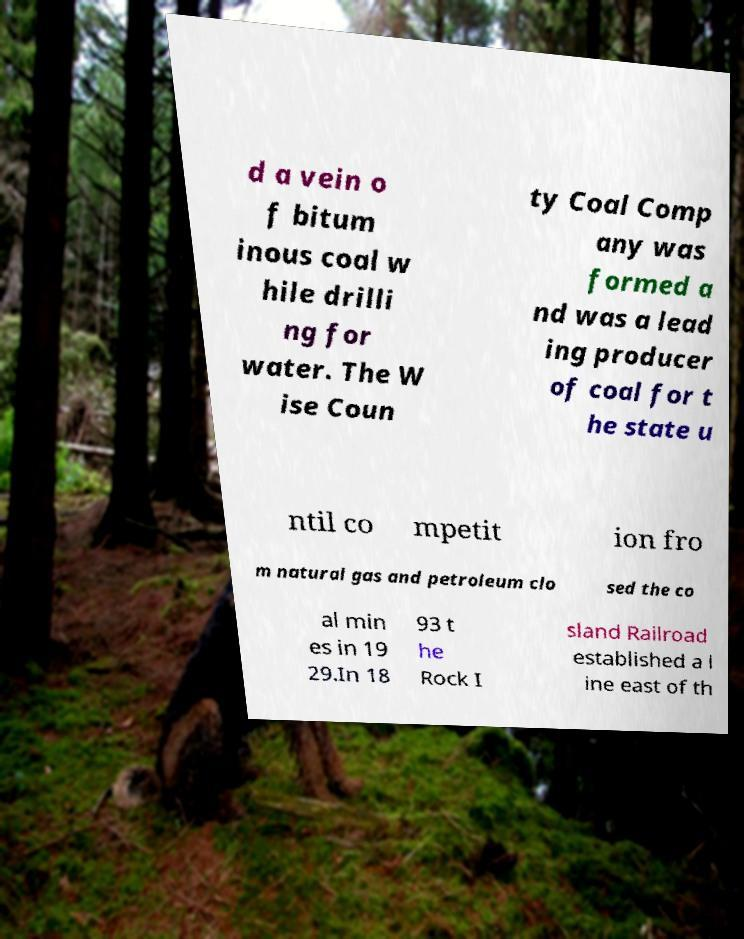Please identify and transcribe the text found in this image. d a vein o f bitum inous coal w hile drilli ng for water. The W ise Coun ty Coal Comp any was formed a nd was a lead ing producer of coal for t he state u ntil co mpetit ion fro m natural gas and petroleum clo sed the co al min es in 19 29.In 18 93 t he Rock I sland Railroad established a l ine east of th 